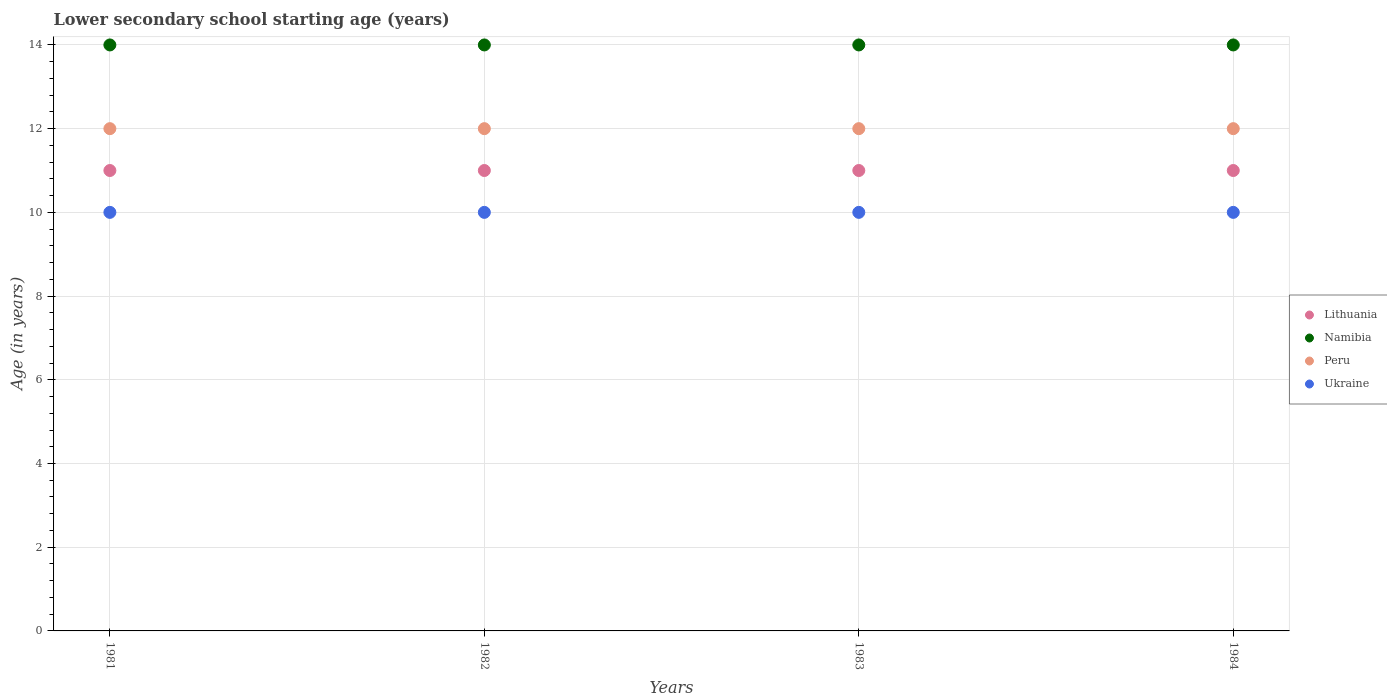How many different coloured dotlines are there?
Provide a succinct answer. 4. What is the lower secondary school starting age of children in Peru in 1982?
Make the answer very short. 12. Across all years, what is the maximum lower secondary school starting age of children in Ukraine?
Your answer should be very brief. 10. Across all years, what is the minimum lower secondary school starting age of children in Ukraine?
Make the answer very short. 10. What is the difference between the lower secondary school starting age of children in Lithuania in 1981 and that in 1983?
Offer a terse response. 0. In how many years, is the lower secondary school starting age of children in Namibia greater than 10 years?
Ensure brevity in your answer.  4. What is the ratio of the lower secondary school starting age of children in Lithuania in 1981 to that in 1983?
Your answer should be very brief. 1. Is the difference between the lower secondary school starting age of children in Peru in 1982 and 1983 greater than the difference between the lower secondary school starting age of children in Lithuania in 1982 and 1983?
Give a very brief answer. No. What is the difference between the highest and the lowest lower secondary school starting age of children in Namibia?
Your response must be concise. 0. Is the sum of the lower secondary school starting age of children in Lithuania in 1981 and 1982 greater than the maximum lower secondary school starting age of children in Peru across all years?
Your answer should be compact. Yes. Is it the case that in every year, the sum of the lower secondary school starting age of children in Ukraine and lower secondary school starting age of children in Peru  is greater than the sum of lower secondary school starting age of children in Namibia and lower secondary school starting age of children in Lithuania?
Provide a succinct answer. No. Does the lower secondary school starting age of children in Lithuania monotonically increase over the years?
Your answer should be compact. No. How many years are there in the graph?
Give a very brief answer. 4. Are the values on the major ticks of Y-axis written in scientific E-notation?
Provide a succinct answer. No. Does the graph contain any zero values?
Provide a succinct answer. No. Does the graph contain grids?
Offer a terse response. Yes. How many legend labels are there?
Ensure brevity in your answer.  4. How are the legend labels stacked?
Offer a very short reply. Vertical. What is the title of the graph?
Offer a terse response. Lower secondary school starting age (years). Does "Palau" appear as one of the legend labels in the graph?
Give a very brief answer. No. What is the label or title of the Y-axis?
Provide a succinct answer. Age (in years). What is the Age (in years) of Namibia in 1981?
Provide a succinct answer. 14. What is the Age (in years) of Peru in 1981?
Provide a succinct answer. 12. What is the Age (in years) of Lithuania in 1982?
Make the answer very short. 11. What is the Age (in years) of Namibia in 1982?
Offer a very short reply. 14. What is the Age (in years) of Ukraine in 1982?
Keep it short and to the point. 10. What is the Age (in years) in Lithuania in 1983?
Keep it short and to the point. 11. What is the Age (in years) of Peru in 1983?
Ensure brevity in your answer.  12. What is the Age (in years) of Ukraine in 1983?
Keep it short and to the point. 10. What is the Age (in years) in Lithuania in 1984?
Your answer should be very brief. 11. What is the Age (in years) of Peru in 1984?
Give a very brief answer. 12. Across all years, what is the maximum Age (in years) of Lithuania?
Make the answer very short. 11. Across all years, what is the maximum Age (in years) in Peru?
Provide a succinct answer. 12. Across all years, what is the maximum Age (in years) of Ukraine?
Provide a short and direct response. 10. Across all years, what is the minimum Age (in years) of Lithuania?
Offer a very short reply. 11. Across all years, what is the minimum Age (in years) of Namibia?
Keep it short and to the point. 14. What is the total Age (in years) in Lithuania in the graph?
Your answer should be very brief. 44. What is the total Age (in years) in Namibia in the graph?
Make the answer very short. 56. What is the total Age (in years) in Ukraine in the graph?
Your answer should be compact. 40. What is the difference between the Age (in years) of Peru in 1981 and that in 1982?
Your answer should be compact. 0. What is the difference between the Age (in years) of Ukraine in 1981 and that in 1984?
Provide a succinct answer. 0. What is the difference between the Age (in years) of Lithuania in 1982 and that in 1983?
Keep it short and to the point. 0. What is the difference between the Age (in years) in Namibia in 1982 and that in 1983?
Keep it short and to the point. 0. What is the difference between the Age (in years) of Peru in 1982 and that in 1983?
Provide a short and direct response. 0. What is the difference between the Age (in years) in Lithuania in 1982 and that in 1984?
Provide a succinct answer. 0. What is the difference between the Age (in years) in Namibia in 1982 and that in 1984?
Ensure brevity in your answer.  0. What is the difference between the Age (in years) in Peru in 1982 and that in 1984?
Your answer should be very brief. 0. What is the difference between the Age (in years) in Ukraine in 1982 and that in 1984?
Your answer should be compact. 0. What is the difference between the Age (in years) of Namibia in 1983 and that in 1984?
Offer a terse response. 0. What is the difference between the Age (in years) in Ukraine in 1983 and that in 1984?
Make the answer very short. 0. What is the difference between the Age (in years) in Lithuania in 1981 and the Age (in years) in Ukraine in 1982?
Your answer should be very brief. 1. What is the difference between the Age (in years) in Namibia in 1981 and the Age (in years) in Ukraine in 1982?
Your response must be concise. 4. What is the difference between the Age (in years) in Peru in 1981 and the Age (in years) in Ukraine in 1982?
Make the answer very short. 2. What is the difference between the Age (in years) of Lithuania in 1981 and the Age (in years) of Namibia in 1983?
Your response must be concise. -3. What is the difference between the Age (in years) of Lithuania in 1981 and the Age (in years) of Peru in 1983?
Keep it short and to the point. -1. What is the difference between the Age (in years) in Namibia in 1981 and the Age (in years) in Peru in 1983?
Make the answer very short. 2. What is the difference between the Age (in years) of Peru in 1981 and the Age (in years) of Ukraine in 1983?
Make the answer very short. 2. What is the difference between the Age (in years) of Lithuania in 1981 and the Age (in years) of Peru in 1984?
Provide a short and direct response. -1. What is the difference between the Age (in years) in Lithuania in 1981 and the Age (in years) in Ukraine in 1984?
Keep it short and to the point. 1. What is the difference between the Age (in years) of Namibia in 1981 and the Age (in years) of Ukraine in 1984?
Your answer should be compact. 4. What is the difference between the Age (in years) of Lithuania in 1982 and the Age (in years) of Peru in 1983?
Provide a succinct answer. -1. What is the difference between the Age (in years) of Lithuania in 1982 and the Age (in years) of Ukraine in 1983?
Provide a short and direct response. 1. What is the difference between the Age (in years) of Namibia in 1982 and the Age (in years) of Ukraine in 1983?
Give a very brief answer. 4. What is the difference between the Age (in years) of Lithuania in 1982 and the Age (in years) of Peru in 1984?
Keep it short and to the point. -1. What is the difference between the Age (in years) in Lithuania in 1982 and the Age (in years) in Ukraine in 1984?
Provide a succinct answer. 1. What is the difference between the Age (in years) of Namibia in 1982 and the Age (in years) of Ukraine in 1984?
Make the answer very short. 4. What is the difference between the Age (in years) of Peru in 1982 and the Age (in years) of Ukraine in 1984?
Provide a short and direct response. 2. What is the difference between the Age (in years) of Lithuania in 1983 and the Age (in years) of Namibia in 1984?
Provide a short and direct response. -3. What is the difference between the Age (in years) of Lithuania in 1983 and the Age (in years) of Peru in 1984?
Offer a very short reply. -1. What is the difference between the Age (in years) in Lithuania in 1983 and the Age (in years) in Ukraine in 1984?
Ensure brevity in your answer.  1. What is the difference between the Age (in years) in Namibia in 1983 and the Age (in years) in Ukraine in 1984?
Provide a succinct answer. 4. What is the difference between the Age (in years) in Peru in 1983 and the Age (in years) in Ukraine in 1984?
Provide a succinct answer. 2. In the year 1981, what is the difference between the Age (in years) of Lithuania and Age (in years) of Peru?
Make the answer very short. -1. In the year 1982, what is the difference between the Age (in years) in Lithuania and Age (in years) in Ukraine?
Your answer should be very brief. 1. In the year 1983, what is the difference between the Age (in years) in Lithuania and Age (in years) in Peru?
Ensure brevity in your answer.  -1. In the year 1984, what is the difference between the Age (in years) in Lithuania and Age (in years) in Namibia?
Your answer should be compact. -3. In the year 1984, what is the difference between the Age (in years) of Lithuania and Age (in years) of Peru?
Your answer should be very brief. -1. In the year 1984, what is the difference between the Age (in years) of Namibia and Age (in years) of Peru?
Your response must be concise. 2. What is the ratio of the Age (in years) in Lithuania in 1981 to that in 1982?
Ensure brevity in your answer.  1. What is the ratio of the Age (in years) in Namibia in 1981 to that in 1982?
Your answer should be compact. 1. What is the ratio of the Age (in years) in Namibia in 1981 to that in 1983?
Your answer should be very brief. 1. What is the ratio of the Age (in years) of Ukraine in 1981 to that in 1983?
Ensure brevity in your answer.  1. What is the ratio of the Age (in years) in Peru in 1981 to that in 1984?
Offer a very short reply. 1. What is the ratio of the Age (in years) of Ukraine in 1982 to that in 1983?
Your response must be concise. 1. What is the ratio of the Age (in years) in Namibia in 1982 to that in 1984?
Offer a very short reply. 1. What is the ratio of the Age (in years) of Peru in 1983 to that in 1984?
Make the answer very short. 1. What is the ratio of the Age (in years) of Ukraine in 1983 to that in 1984?
Provide a short and direct response. 1. What is the difference between the highest and the lowest Age (in years) in Lithuania?
Provide a short and direct response. 0. What is the difference between the highest and the lowest Age (in years) in Ukraine?
Your answer should be compact. 0. 